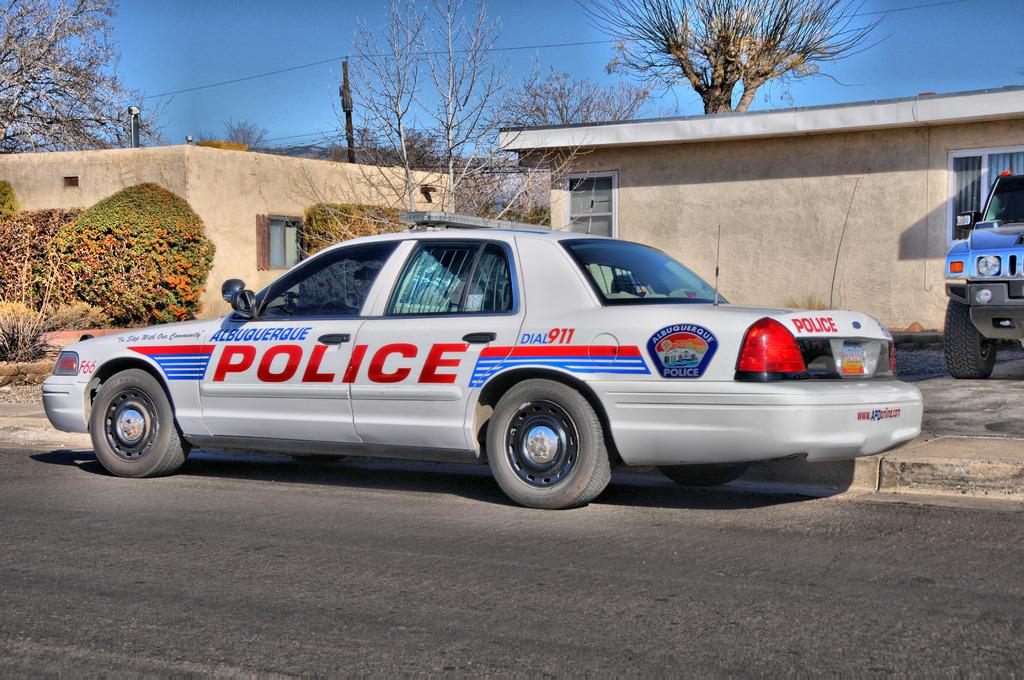Which public service department operates this vehicle?
Give a very brief answer. Police. What town is this cop from?
Your answer should be very brief. Albuquerque. 